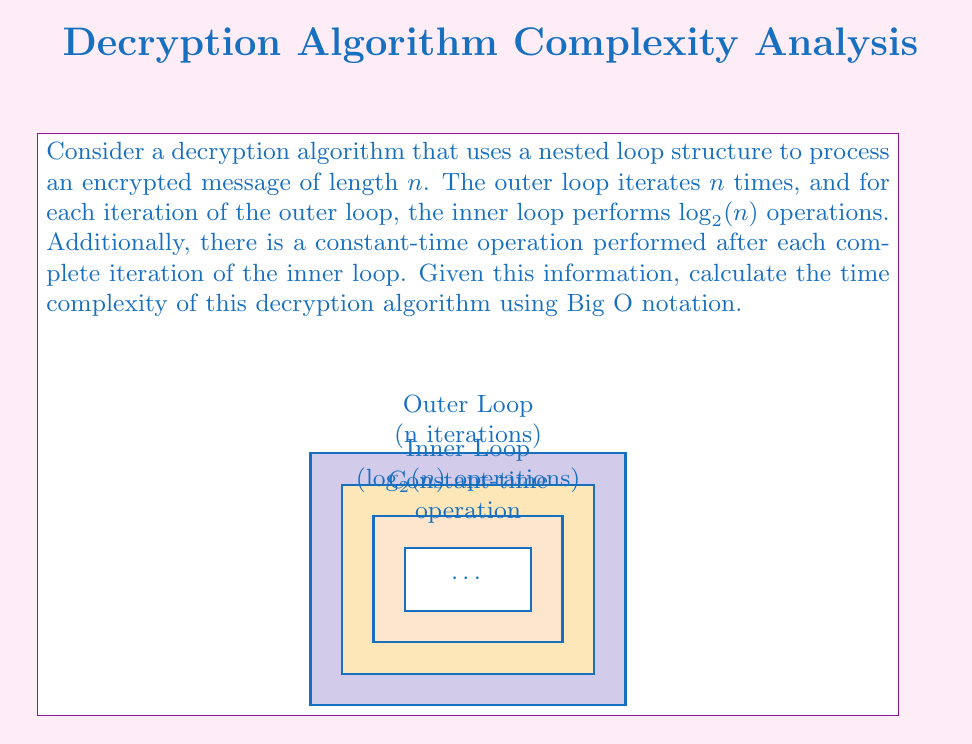Can you answer this question? To calculate the time complexity of this decryption algorithm, we need to analyze the nested loop structure and the additional constant-time operation:

1. The outer loop runs $n$ times.

2. For each iteration of the outer loop:
   a. The inner loop performs $\log_2(n)$ operations.
   b. A constant-time operation is performed after the inner loop.

3. Let's break down the total number of operations:
   - Inner loop operations: $n \cdot \log_2(n)$
   - Constant-time operations: $n \cdot O(1) = O(n)$

4. The total time complexity is the sum of these operations:
   $T(n) = n \cdot \log_2(n) + O(n)$

5. In Big O notation, we focus on the dominant term as $n$ grows large. Between $n \cdot \log_2(n)$ and $O(n)$, the $n \cdot \log_2(n)$ term grows faster for large $n$.

6. Therefore, we can express the time complexity as:
   $T(n) = O(n \log n)$

This means that the time complexity of the decryption algorithm grows in proportion to $n \log n$, where $n$ is the length of the encrypted message.
Answer: $O(n \log n)$ 